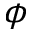Convert formula to latex. <formula><loc_0><loc_0><loc_500><loc_500>\phi</formula> 